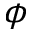Convert formula to latex. <formula><loc_0><loc_0><loc_500><loc_500>\phi</formula> 